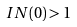<formula> <loc_0><loc_0><loc_500><loc_500>I N ( 0 ) > 1</formula> 